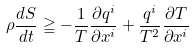<formula> <loc_0><loc_0><loc_500><loc_500>\rho \frac { d S } { d t } \geqq - \frac { 1 } { T } \frac { \partial q ^ { i } } { \partial x ^ { i } } + \frac { q ^ { i } } { T ^ { 2 } } \frac { \partial T } { \partial x ^ { i } }</formula> 